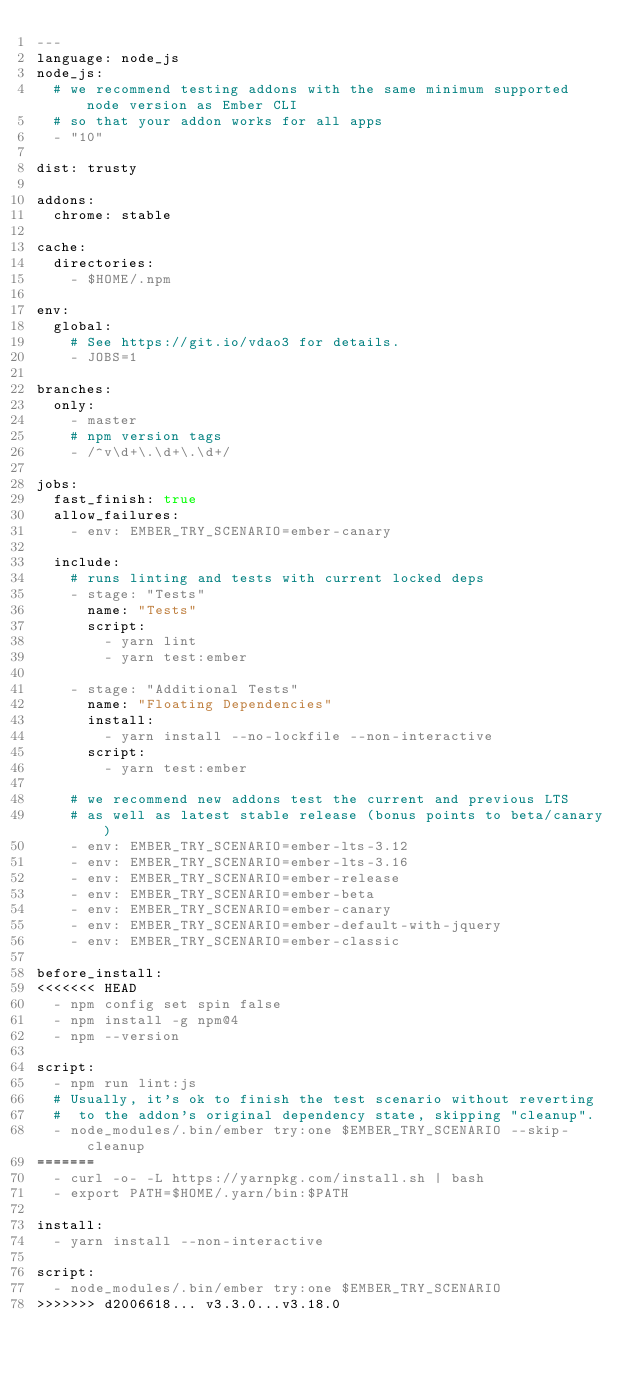Convert code to text. <code><loc_0><loc_0><loc_500><loc_500><_YAML_>---
language: node_js
node_js:
  # we recommend testing addons with the same minimum supported node version as Ember CLI
  # so that your addon works for all apps
  - "10"

dist: trusty

addons:
  chrome: stable

cache:
  directories:
    - $HOME/.npm

env:
  global:
    # See https://git.io/vdao3 for details.
    - JOBS=1

branches:
  only:
    - master
    # npm version tags
    - /^v\d+\.\d+\.\d+/

jobs:
  fast_finish: true
  allow_failures:
    - env: EMBER_TRY_SCENARIO=ember-canary

  include:
    # runs linting and tests with current locked deps
    - stage: "Tests"
      name: "Tests"
      script:
        - yarn lint
        - yarn test:ember

    - stage: "Additional Tests"
      name: "Floating Dependencies"
      install:
        - yarn install --no-lockfile --non-interactive
      script:
        - yarn test:ember

    # we recommend new addons test the current and previous LTS
    # as well as latest stable release (bonus points to beta/canary)
    - env: EMBER_TRY_SCENARIO=ember-lts-3.12
    - env: EMBER_TRY_SCENARIO=ember-lts-3.16
    - env: EMBER_TRY_SCENARIO=ember-release
    - env: EMBER_TRY_SCENARIO=ember-beta
    - env: EMBER_TRY_SCENARIO=ember-canary
    - env: EMBER_TRY_SCENARIO=ember-default-with-jquery
    - env: EMBER_TRY_SCENARIO=ember-classic

before_install:
<<<<<<< HEAD
  - npm config set spin false
  - npm install -g npm@4
  - npm --version

script:
  - npm run lint:js
  # Usually, it's ok to finish the test scenario without reverting
  #  to the addon's original dependency state, skipping "cleanup".
  - node_modules/.bin/ember try:one $EMBER_TRY_SCENARIO --skip-cleanup
=======
  - curl -o- -L https://yarnpkg.com/install.sh | bash
  - export PATH=$HOME/.yarn/bin:$PATH

install:
  - yarn install --non-interactive

script:
  - node_modules/.bin/ember try:one $EMBER_TRY_SCENARIO
>>>>>>> d2006618... v3.3.0...v3.18.0
</code> 